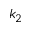<formula> <loc_0><loc_0><loc_500><loc_500>k _ { 2 }</formula> 